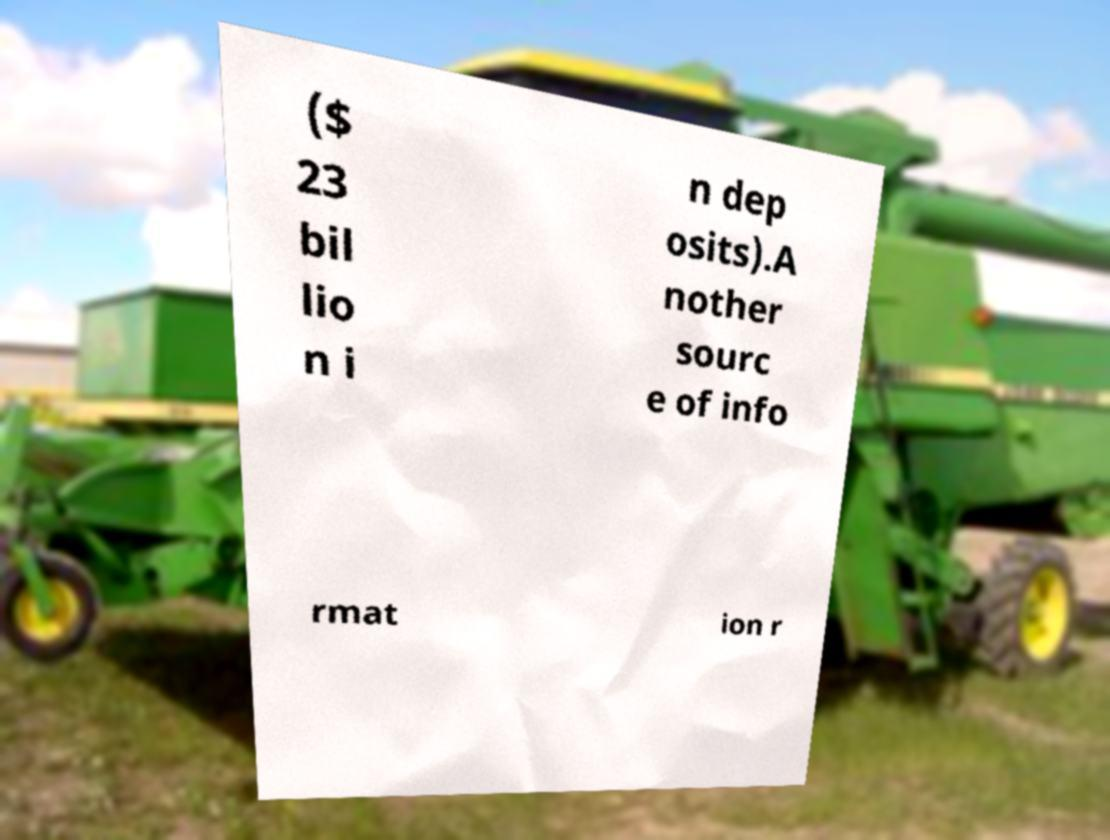Can you read and provide the text displayed in the image?This photo seems to have some interesting text. Can you extract and type it out for me? ($ 23 bil lio n i n dep osits).A nother sourc e of info rmat ion r 